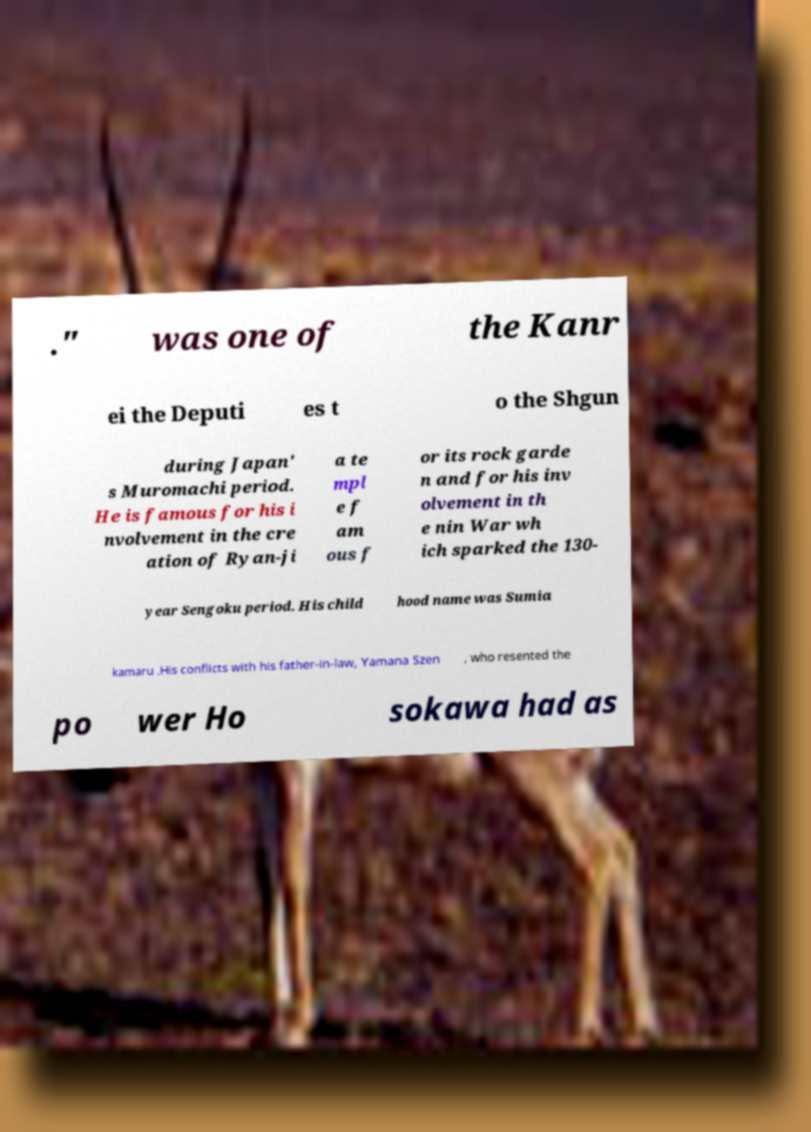Could you assist in decoding the text presented in this image and type it out clearly? ." was one of the Kanr ei the Deputi es t o the Shgun during Japan' s Muromachi period. He is famous for his i nvolvement in the cre ation of Ryan-ji a te mpl e f am ous f or its rock garde n and for his inv olvement in th e nin War wh ich sparked the 130- year Sengoku period. His child hood name was Sumia kamaru .His conflicts with his father-in-law, Yamana Szen , who resented the po wer Ho sokawa had as 